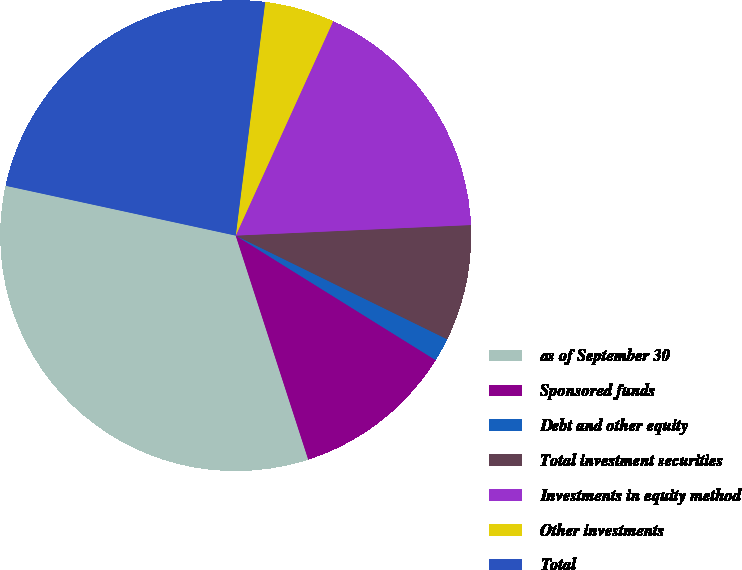Convert chart to OTSL. <chart><loc_0><loc_0><loc_500><loc_500><pie_chart><fcel>as of September 30<fcel>Sponsored funds<fcel>Debt and other equity<fcel>Total investment securities<fcel>Investments in equity method<fcel>Other investments<fcel>Total<nl><fcel>33.38%<fcel>11.15%<fcel>1.61%<fcel>7.97%<fcel>17.5%<fcel>4.79%<fcel>23.6%<nl></chart> 